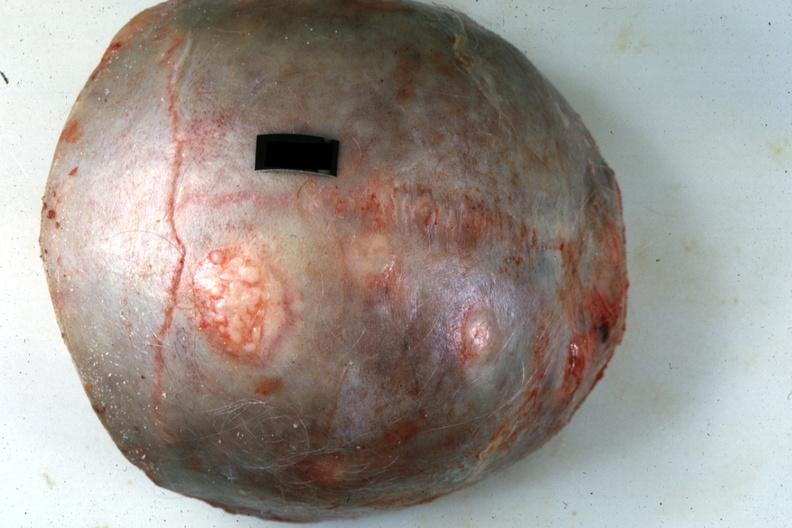s cytomegalovirus present?
Answer the question using a single word or phrase. No 